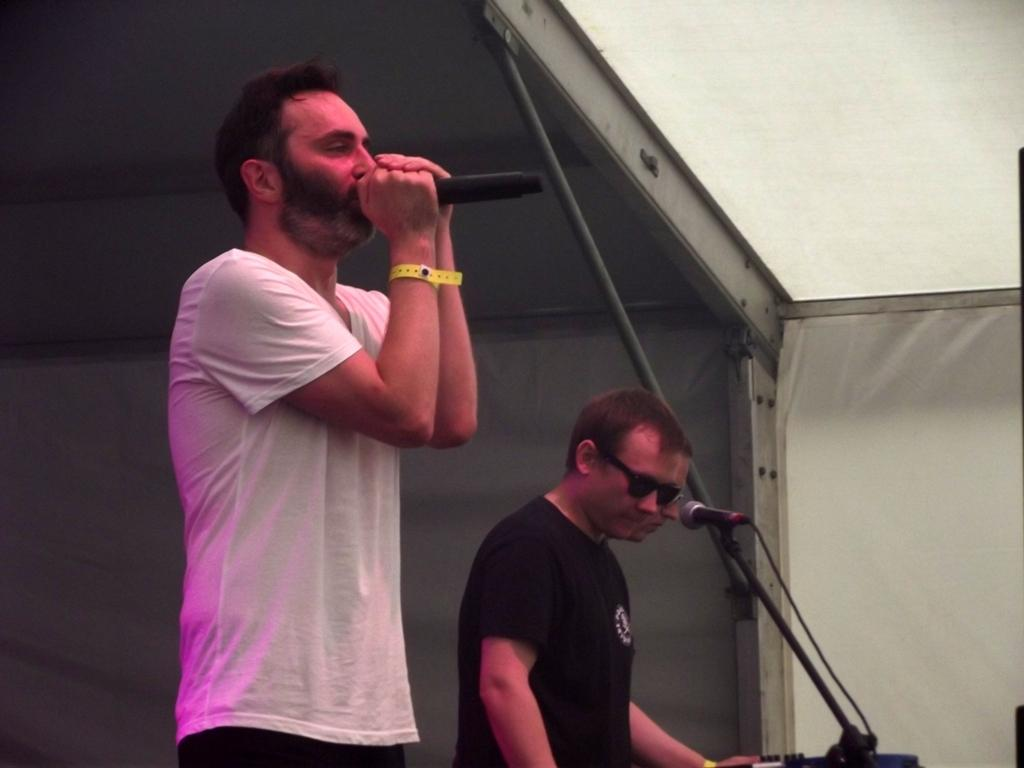What are the people in the image doing? The people in the image are standing. Can you identify any specific objects that one of the people is holding? Yes, one person is holding a microphone. What type of structure can be seen in the image? There is a shed in the image. What is the color of the cloth visible in the image? The cloth in the image is white. What type of insurance policy is being discussed by the people holding the rifle in the image? There is no rifle present in the image, and therefore no discussion about insurance policies can be observed. 